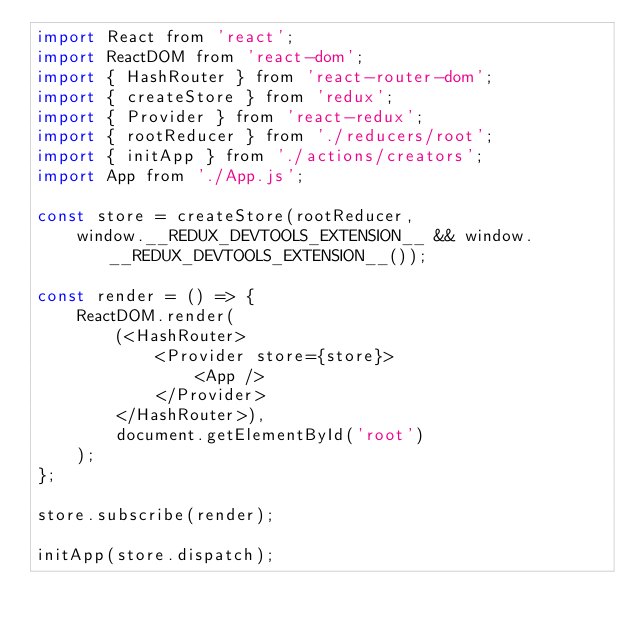<code> <loc_0><loc_0><loc_500><loc_500><_JavaScript_>import React from 'react';
import ReactDOM from 'react-dom';
import { HashRouter } from 'react-router-dom';
import { createStore } from 'redux';
import { Provider } from 'react-redux';
import { rootReducer } from './reducers/root';
import { initApp } from './actions/creators';
import App from './App.js';

const store = createStore(rootReducer,
	window.__REDUX_DEVTOOLS_EXTENSION__ && window.__REDUX_DEVTOOLS_EXTENSION__());

const render = () => {
	ReactDOM.render(
		(<HashRouter>
			<Provider store={store}>
				<App />
			</Provider>
		</HashRouter>),
		document.getElementById('root')
	);
};

store.subscribe(render);

initApp(store.dispatch);
</code> 